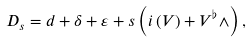Convert formula to latex. <formula><loc_0><loc_0><loc_500><loc_500>D _ { s } = d + \delta + \varepsilon + s \left ( i \left ( V \right ) + V ^ { \flat } \wedge \right ) ,</formula> 